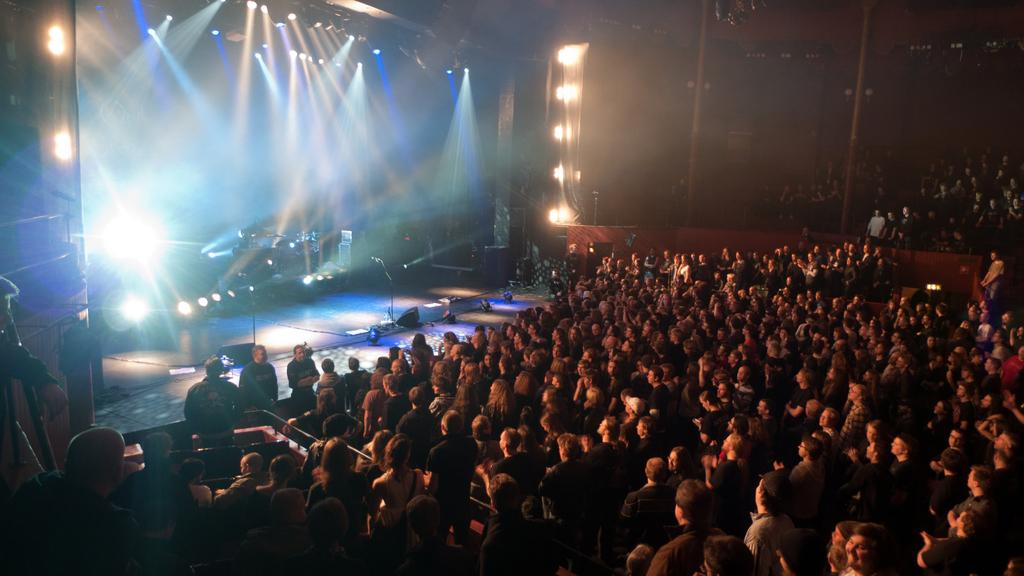How many people are visible in the image? There are many people in the image. What are the people in the image doing? The people are standing. What can be seen at the top of the image? There are lights at the top of the image. Where is the stage located in the image? The stage is on the left side of the image. What is present on the stage? There are musical instruments and microphones on the stage, as well as additional lights. What type of breakfast is being served on the bed in the image? There is no bed or breakfast present in the image. How many cats can be seen playing with the musical instruments on the stage? There are no cats present in the image, and there is no musical instrument being played. 